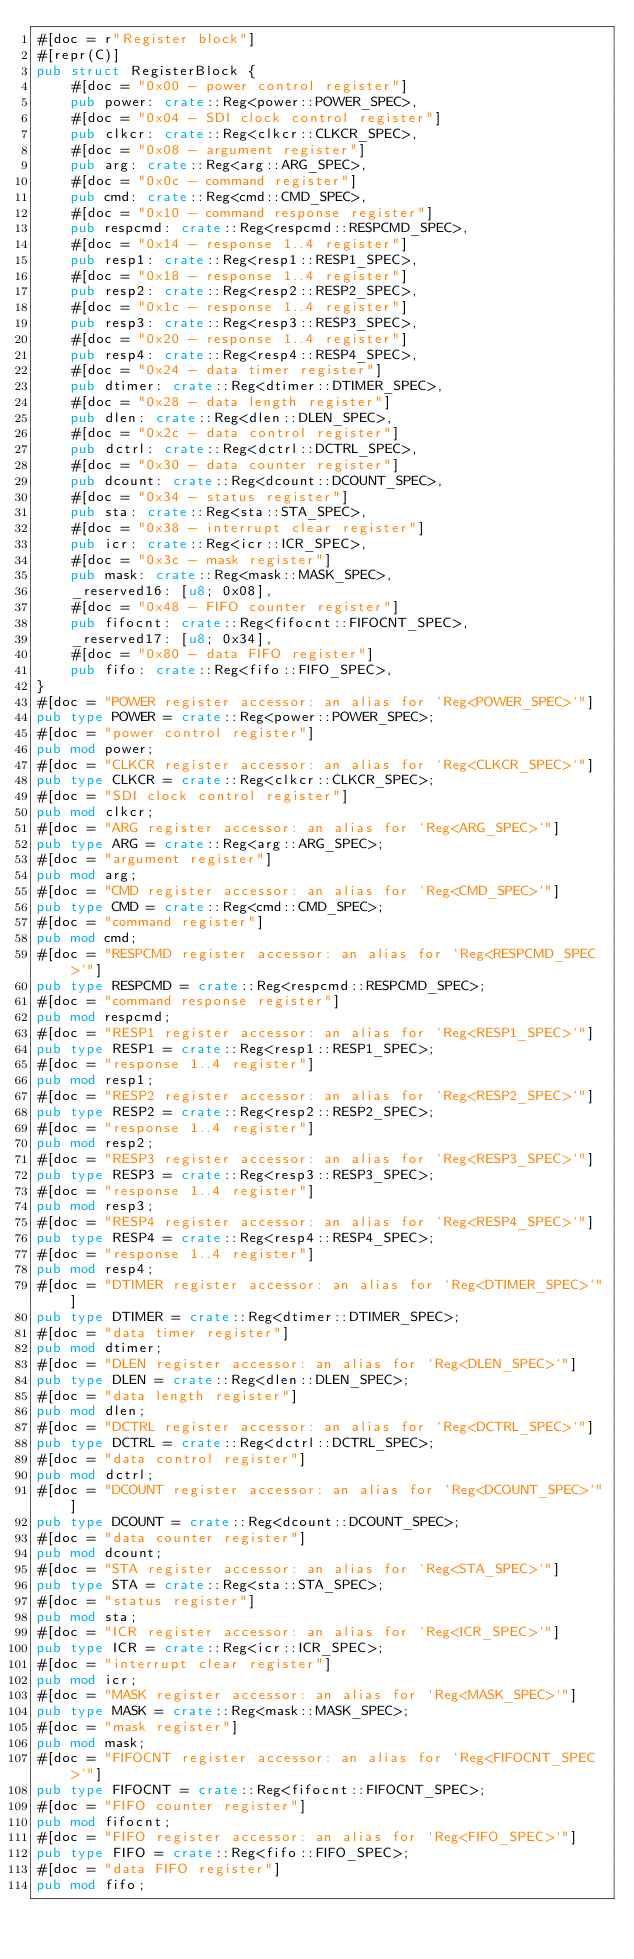<code> <loc_0><loc_0><loc_500><loc_500><_Rust_>#[doc = r"Register block"]
#[repr(C)]
pub struct RegisterBlock {
    #[doc = "0x00 - power control register"]
    pub power: crate::Reg<power::POWER_SPEC>,
    #[doc = "0x04 - SDI clock control register"]
    pub clkcr: crate::Reg<clkcr::CLKCR_SPEC>,
    #[doc = "0x08 - argument register"]
    pub arg: crate::Reg<arg::ARG_SPEC>,
    #[doc = "0x0c - command register"]
    pub cmd: crate::Reg<cmd::CMD_SPEC>,
    #[doc = "0x10 - command response register"]
    pub respcmd: crate::Reg<respcmd::RESPCMD_SPEC>,
    #[doc = "0x14 - response 1..4 register"]
    pub resp1: crate::Reg<resp1::RESP1_SPEC>,
    #[doc = "0x18 - response 1..4 register"]
    pub resp2: crate::Reg<resp2::RESP2_SPEC>,
    #[doc = "0x1c - response 1..4 register"]
    pub resp3: crate::Reg<resp3::RESP3_SPEC>,
    #[doc = "0x20 - response 1..4 register"]
    pub resp4: crate::Reg<resp4::RESP4_SPEC>,
    #[doc = "0x24 - data timer register"]
    pub dtimer: crate::Reg<dtimer::DTIMER_SPEC>,
    #[doc = "0x28 - data length register"]
    pub dlen: crate::Reg<dlen::DLEN_SPEC>,
    #[doc = "0x2c - data control register"]
    pub dctrl: crate::Reg<dctrl::DCTRL_SPEC>,
    #[doc = "0x30 - data counter register"]
    pub dcount: crate::Reg<dcount::DCOUNT_SPEC>,
    #[doc = "0x34 - status register"]
    pub sta: crate::Reg<sta::STA_SPEC>,
    #[doc = "0x38 - interrupt clear register"]
    pub icr: crate::Reg<icr::ICR_SPEC>,
    #[doc = "0x3c - mask register"]
    pub mask: crate::Reg<mask::MASK_SPEC>,
    _reserved16: [u8; 0x08],
    #[doc = "0x48 - FIFO counter register"]
    pub fifocnt: crate::Reg<fifocnt::FIFOCNT_SPEC>,
    _reserved17: [u8; 0x34],
    #[doc = "0x80 - data FIFO register"]
    pub fifo: crate::Reg<fifo::FIFO_SPEC>,
}
#[doc = "POWER register accessor: an alias for `Reg<POWER_SPEC>`"]
pub type POWER = crate::Reg<power::POWER_SPEC>;
#[doc = "power control register"]
pub mod power;
#[doc = "CLKCR register accessor: an alias for `Reg<CLKCR_SPEC>`"]
pub type CLKCR = crate::Reg<clkcr::CLKCR_SPEC>;
#[doc = "SDI clock control register"]
pub mod clkcr;
#[doc = "ARG register accessor: an alias for `Reg<ARG_SPEC>`"]
pub type ARG = crate::Reg<arg::ARG_SPEC>;
#[doc = "argument register"]
pub mod arg;
#[doc = "CMD register accessor: an alias for `Reg<CMD_SPEC>`"]
pub type CMD = crate::Reg<cmd::CMD_SPEC>;
#[doc = "command register"]
pub mod cmd;
#[doc = "RESPCMD register accessor: an alias for `Reg<RESPCMD_SPEC>`"]
pub type RESPCMD = crate::Reg<respcmd::RESPCMD_SPEC>;
#[doc = "command response register"]
pub mod respcmd;
#[doc = "RESP1 register accessor: an alias for `Reg<RESP1_SPEC>`"]
pub type RESP1 = crate::Reg<resp1::RESP1_SPEC>;
#[doc = "response 1..4 register"]
pub mod resp1;
#[doc = "RESP2 register accessor: an alias for `Reg<RESP2_SPEC>`"]
pub type RESP2 = crate::Reg<resp2::RESP2_SPEC>;
#[doc = "response 1..4 register"]
pub mod resp2;
#[doc = "RESP3 register accessor: an alias for `Reg<RESP3_SPEC>`"]
pub type RESP3 = crate::Reg<resp3::RESP3_SPEC>;
#[doc = "response 1..4 register"]
pub mod resp3;
#[doc = "RESP4 register accessor: an alias for `Reg<RESP4_SPEC>`"]
pub type RESP4 = crate::Reg<resp4::RESP4_SPEC>;
#[doc = "response 1..4 register"]
pub mod resp4;
#[doc = "DTIMER register accessor: an alias for `Reg<DTIMER_SPEC>`"]
pub type DTIMER = crate::Reg<dtimer::DTIMER_SPEC>;
#[doc = "data timer register"]
pub mod dtimer;
#[doc = "DLEN register accessor: an alias for `Reg<DLEN_SPEC>`"]
pub type DLEN = crate::Reg<dlen::DLEN_SPEC>;
#[doc = "data length register"]
pub mod dlen;
#[doc = "DCTRL register accessor: an alias for `Reg<DCTRL_SPEC>`"]
pub type DCTRL = crate::Reg<dctrl::DCTRL_SPEC>;
#[doc = "data control register"]
pub mod dctrl;
#[doc = "DCOUNT register accessor: an alias for `Reg<DCOUNT_SPEC>`"]
pub type DCOUNT = crate::Reg<dcount::DCOUNT_SPEC>;
#[doc = "data counter register"]
pub mod dcount;
#[doc = "STA register accessor: an alias for `Reg<STA_SPEC>`"]
pub type STA = crate::Reg<sta::STA_SPEC>;
#[doc = "status register"]
pub mod sta;
#[doc = "ICR register accessor: an alias for `Reg<ICR_SPEC>`"]
pub type ICR = crate::Reg<icr::ICR_SPEC>;
#[doc = "interrupt clear register"]
pub mod icr;
#[doc = "MASK register accessor: an alias for `Reg<MASK_SPEC>`"]
pub type MASK = crate::Reg<mask::MASK_SPEC>;
#[doc = "mask register"]
pub mod mask;
#[doc = "FIFOCNT register accessor: an alias for `Reg<FIFOCNT_SPEC>`"]
pub type FIFOCNT = crate::Reg<fifocnt::FIFOCNT_SPEC>;
#[doc = "FIFO counter register"]
pub mod fifocnt;
#[doc = "FIFO register accessor: an alias for `Reg<FIFO_SPEC>`"]
pub type FIFO = crate::Reg<fifo::FIFO_SPEC>;
#[doc = "data FIFO register"]
pub mod fifo;
</code> 